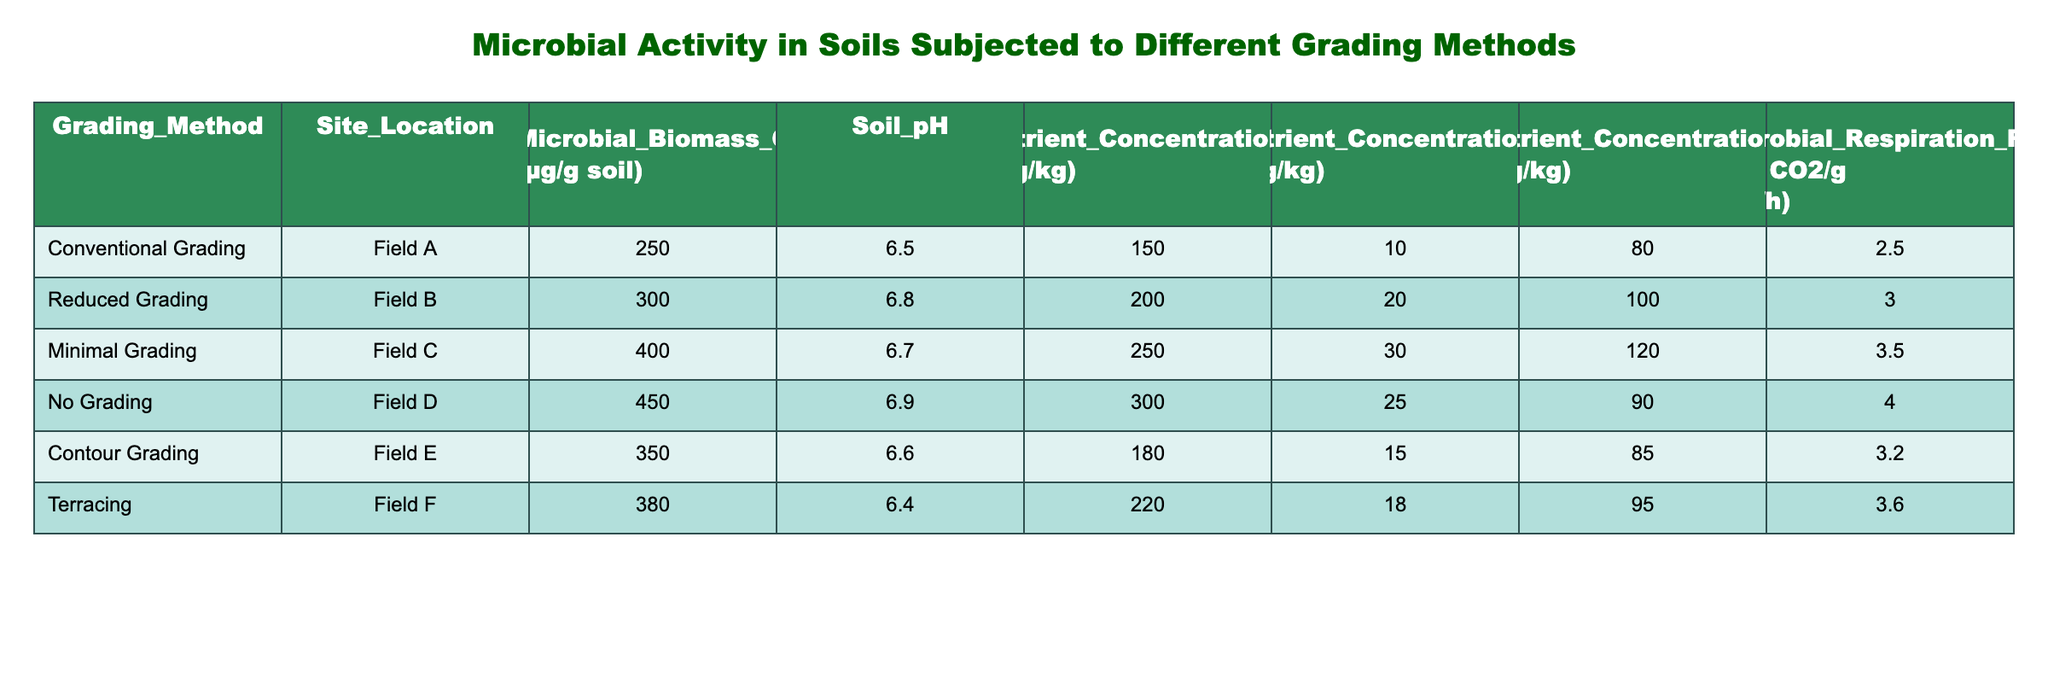What is the microbial biomass carbon for Minimal Grading? The table lists the microbial biomass carbon values for different grading methods. For the Minimal Grading method, the value is clearly indicated as 400 μg/g soil.
Answer: 400 μg/g soil Which grading method has the highest microbial respiration rate? By examining the last column of the table, we can see that the No Grading method has the highest microbial respiration rate listed at 4.0 mg CO2/g soil/h, which is greater than all the other methods presented.
Answer: No Grading What is the difference in microbial biomass carbon between Conventional Grading and No Grading? The microbial biomass carbon for Conventional Grading is 250 μg/g soil, while for No Grading it is 450 μg/g soil. The difference can be calculated as 450 - 250 = 200 μg/g soil.
Answer: 200 μg/g soil Is the soil pH for Contour Grading greater than 6.7? Looking at the pH values in the corresponding row for Contour Grading, the value is 6.6, which is not greater than 6.7. Therefore, the answer is no.
Answer: No What is the average nutrient concentration of Nitrogen for all grading methods listed? To find the average, we first sum the nitrogen values: 150 + 200 + 250 + 300 + 180 + 220 = 1300 mg/kg. Next, we divide the sum by the number of grading methods (6). The average is 1300 / 6 = approximately 216.67 mg/kg.
Answer: 216.67 mg/kg How does the nutrient concentration of Potassium compare between Reduced Grading and Terracing? The nutrient concentration of Potassium for Reduced Grading is 100 mg/kg, while for Terracing it is 95 mg/kg. Reduced Grading has a higher concentration than Terracing, thus confirming this comparison.
Answer: Reduced Grading is higher Which grading method shows the least nutrient concentration of Phosphorus? The table shows nutrient concentrations of Phosphorus for different grading methods: 10, 20, 30, 25, 15, 18 mg/kg. The least is found for Conventional Grading with a value of 10 mg/kg.
Answer: Conventional Grading Which grading method has the combination of the highest microbial biomass carbon and lowest soil pH? Evaluating the microbial biomass carbon and soil pH together: No Grading has the highest microbial biomass (450 μg/g soil) but a higher pH (6.9); Minimal Grading has high biomass (400 μg/g soil) with a pH of 6.7; Thus, we compare these values across methods. The best combination is Minimal Grading for high biomass and lower pH at 6.7.
Answer: Minimal Grading 